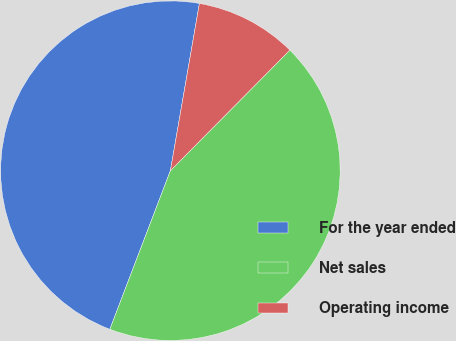Convert chart. <chart><loc_0><loc_0><loc_500><loc_500><pie_chart><fcel>For the year ended<fcel>Net sales<fcel>Operating income<nl><fcel>46.93%<fcel>43.38%<fcel>9.69%<nl></chart> 